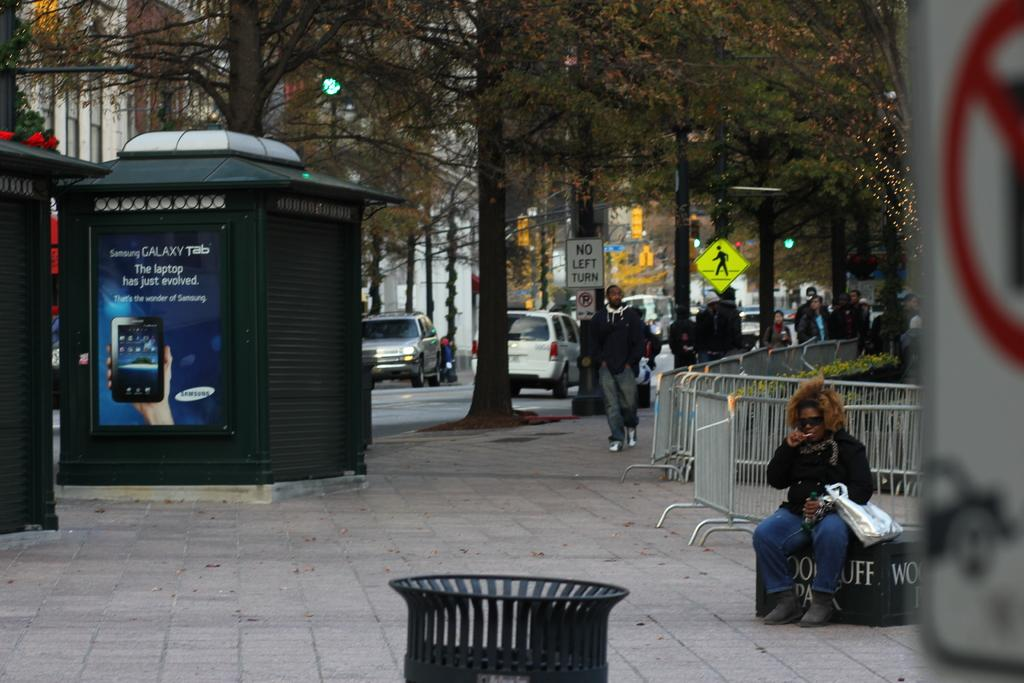<image>
Create a compact narrative representing the image presented. an ad for Samsung Galaxy Tab on a kiosk near a park 